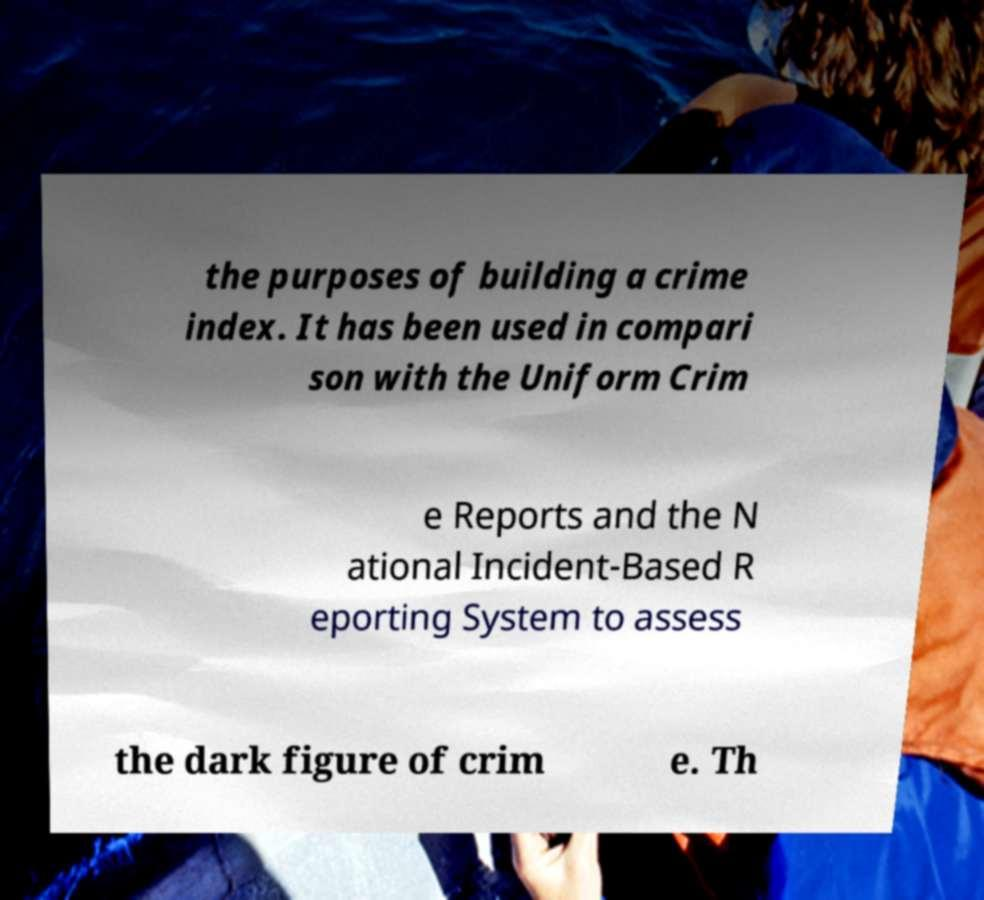Please identify and transcribe the text found in this image. the purposes of building a crime index. It has been used in compari son with the Uniform Crim e Reports and the N ational Incident-Based R eporting System to assess the dark figure of crim e. Th 